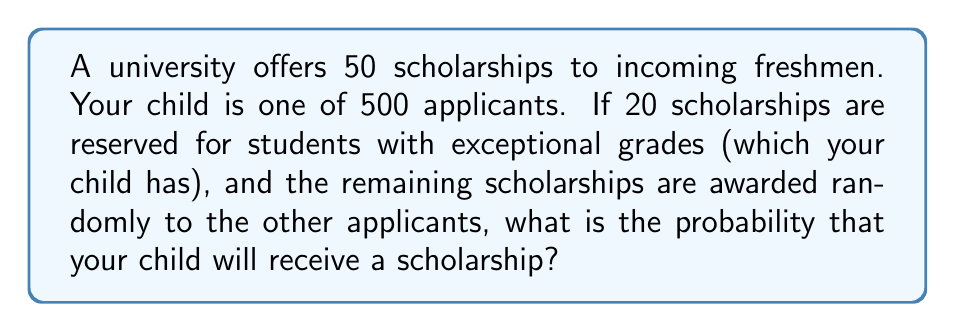Provide a solution to this math problem. Let's approach this step-by-step:

1) First, we need to calculate the probability of your child getting one of the 20 scholarships reserved for students with exceptional grades.

   - Assume there are 100 students with exceptional grades (including your child).
   - Probability = $\frac{\text{favorable outcomes}}{\text{total outcomes}} = \frac{20}{100} = \frac{1}{5} = 0.2$

2) If your child doesn't get one of these 20 scholarships, they still have a chance at the remaining 30 scholarships.

3) For the remaining scholarships:
   - There are now 480 applicants (500 - 20 who got the first set of scholarships)
   - 30 scholarships are available

   Probability = $\frac{30}{480} = \frac{1}{16} = 0.0625$

4) The total probability is the sum of:
   (Probability of getting one of the 20 scholarships) + 
   (Probability of not getting one of the 20 scholarships AND getting one of the 30 scholarships)

5) We can express this mathematically as:

   $$P(\text{scholarship}) = 0.2 + (1 - 0.2) \times 0.0625$$

6) Let's calculate:
   $$P(\text{scholarship}) = 0.2 + 0.8 \times 0.0625 = 0.2 + 0.05 = 0.25$$

Therefore, the probability of your child receiving a scholarship is 0.25 or 25%.
Answer: 0.25 